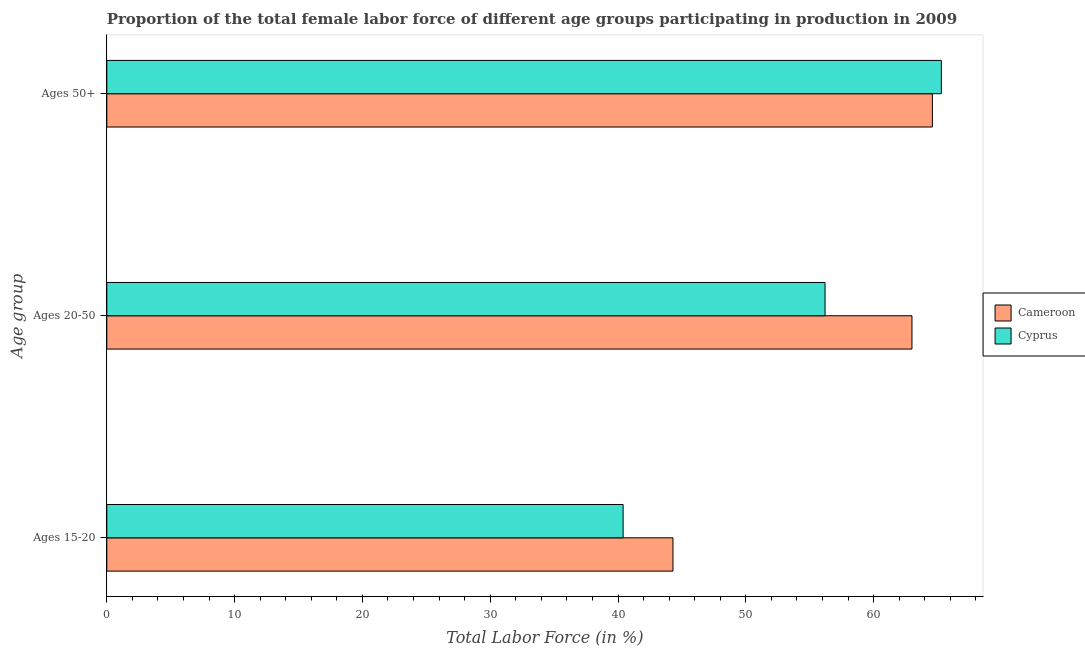How many groups of bars are there?
Provide a succinct answer. 3. Are the number of bars per tick equal to the number of legend labels?
Make the answer very short. Yes. How many bars are there on the 2nd tick from the bottom?
Offer a terse response. 2. What is the label of the 1st group of bars from the top?
Make the answer very short. Ages 50+. What is the percentage of female labor force within the age group 20-50 in Cameroon?
Keep it short and to the point. 63. Across all countries, what is the maximum percentage of female labor force above age 50?
Give a very brief answer. 65.3. Across all countries, what is the minimum percentage of female labor force within the age group 20-50?
Provide a short and direct response. 56.2. In which country was the percentage of female labor force within the age group 15-20 maximum?
Your response must be concise. Cameroon. In which country was the percentage of female labor force within the age group 15-20 minimum?
Ensure brevity in your answer.  Cyprus. What is the total percentage of female labor force within the age group 15-20 in the graph?
Keep it short and to the point. 84.7. What is the difference between the percentage of female labor force within the age group 20-50 in Cyprus and that in Cameroon?
Your answer should be very brief. -6.8. What is the difference between the percentage of female labor force above age 50 in Cyprus and the percentage of female labor force within the age group 15-20 in Cameroon?
Provide a succinct answer. 21. What is the average percentage of female labor force within the age group 20-50 per country?
Your answer should be very brief. 59.6. What is the difference between the percentage of female labor force above age 50 and percentage of female labor force within the age group 15-20 in Cameroon?
Keep it short and to the point. 20.3. In how many countries, is the percentage of female labor force within the age group 20-50 greater than 10 %?
Provide a short and direct response. 2. What is the ratio of the percentage of female labor force within the age group 15-20 in Cyprus to that in Cameroon?
Your answer should be very brief. 0.91. Is the difference between the percentage of female labor force above age 50 in Cyprus and Cameroon greater than the difference between the percentage of female labor force within the age group 15-20 in Cyprus and Cameroon?
Make the answer very short. Yes. What is the difference between the highest and the second highest percentage of female labor force within the age group 20-50?
Your answer should be compact. 6.8. What is the difference between the highest and the lowest percentage of female labor force above age 50?
Offer a very short reply. 0.7. In how many countries, is the percentage of female labor force within the age group 15-20 greater than the average percentage of female labor force within the age group 15-20 taken over all countries?
Offer a very short reply. 1. Is the sum of the percentage of female labor force within the age group 15-20 in Cyprus and Cameroon greater than the maximum percentage of female labor force within the age group 20-50 across all countries?
Give a very brief answer. Yes. What does the 2nd bar from the top in Ages 20-50 represents?
Give a very brief answer. Cameroon. What does the 1st bar from the bottom in Ages 50+ represents?
Keep it short and to the point. Cameroon. Is it the case that in every country, the sum of the percentage of female labor force within the age group 15-20 and percentage of female labor force within the age group 20-50 is greater than the percentage of female labor force above age 50?
Ensure brevity in your answer.  Yes. How many bars are there?
Ensure brevity in your answer.  6. How many countries are there in the graph?
Ensure brevity in your answer.  2. Are the values on the major ticks of X-axis written in scientific E-notation?
Provide a short and direct response. No. Does the graph contain any zero values?
Your answer should be compact. No. Does the graph contain grids?
Your answer should be compact. No. Where does the legend appear in the graph?
Offer a very short reply. Center right. How are the legend labels stacked?
Your answer should be very brief. Vertical. What is the title of the graph?
Ensure brevity in your answer.  Proportion of the total female labor force of different age groups participating in production in 2009. What is the label or title of the Y-axis?
Offer a terse response. Age group. What is the Total Labor Force (in %) of Cameroon in Ages 15-20?
Offer a terse response. 44.3. What is the Total Labor Force (in %) of Cyprus in Ages 15-20?
Provide a succinct answer. 40.4. What is the Total Labor Force (in %) of Cameroon in Ages 20-50?
Keep it short and to the point. 63. What is the Total Labor Force (in %) in Cyprus in Ages 20-50?
Offer a very short reply. 56.2. What is the Total Labor Force (in %) of Cameroon in Ages 50+?
Ensure brevity in your answer.  64.6. What is the Total Labor Force (in %) in Cyprus in Ages 50+?
Your response must be concise. 65.3. Across all Age group, what is the maximum Total Labor Force (in %) in Cameroon?
Your response must be concise. 64.6. Across all Age group, what is the maximum Total Labor Force (in %) in Cyprus?
Ensure brevity in your answer.  65.3. Across all Age group, what is the minimum Total Labor Force (in %) of Cameroon?
Ensure brevity in your answer.  44.3. Across all Age group, what is the minimum Total Labor Force (in %) in Cyprus?
Give a very brief answer. 40.4. What is the total Total Labor Force (in %) of Cameroon in the graph?
Give a very brief answer. 171.9. What is the total Total Labor Force (in %) in Cyprus in the graph?
Provide a succinct answer. 161.9. What is the difference between the Total Labor Force (in %) of Cameroon in Ages 15-20 and that in Ages 20-50?
Provide a short and direct response. -18.7. What is the difference between the Total Labor Force (in %) of Cyprus in Ages 15-20 and that in Ages 20-50?
Offer a terse response. -15.8. What is the difference between the Total Labor Force (in %) of Cameroon in Ages 15-20 and that in Ages 50+?
Ensure brevity in your answer.  -20.3. What is the difference between the Total Labor Force (in %) in Cyprus in Ages 15-20 and that in Ages 50+?
Make the answer very short. -24.9. What is the difference between the Total Labor Force (in %) of Cyprus in Ages 20-50 and that in Ages 50+?
Offer a very short reply. -9.1. What is the difference between the Total Labor Force (in %) in Cameroon in Ages 15-20 and the Total Labor Force (in %) in Cyprus in Ages 20-50?
Make the answer very short. -11.9. What is the average Total Labor Force (in %) of Cameroon per Age group?
Your response must be concise. 57.3. What is the average Total Labor Force (in %) of Cyprus per Age group?
Provide a short and direct response. 53.97. What is the difference between the Total Labor Force (in %) of Cameroon and Total Labor Force (in %) of Cyprus in Ages 20-50?
Provide a succinct answer. 6.8. What is the ratio of the Total Labor Force (in %) of Cameroon in Ages 15-20 to that in Ages 20-50?
Keep it short and to the point. 0.7. What is the ratio of the Total Labor Force (in %) of Cyprus in Ages 15-20 to that in Ages 20-50?
Offer a very short reply. 0.72. What is the ratio of the Total Labor Force (in %) of Cameroon in Ages 15-20 to that in Ages 50+?
Your answer should be very brief. 0.69. What is the ratio of the Total Labor Force (in %) of Cyprus in Ages 15-20 to that in Ages 50+?
Give a very brief answer. 0.62. What is the ratio of the Total Labor Force (in %) of Cameroon in Ages 20-50 to that in Ages 50+?
Ensure brevity in your answer.  0.98. What is the ratio of the Total Labor Force (in %) in Cyprus in Ages 20-50 to that in Ages 50+?
Your response must be concise. 0.86. What is the difference between the highest and the second highest Total Labor Force (in %) in Cyprus?
Offer a terse response. 9.1. What is the difference between the highest and the lowest Total Labor Force (in %) of Cameroon?
Offer a very short reply. 20.3. What is the difference between the highest and the lowest Total Labor Force (in %) of Cyprus?
Your answer should be very brief. 24.9. 